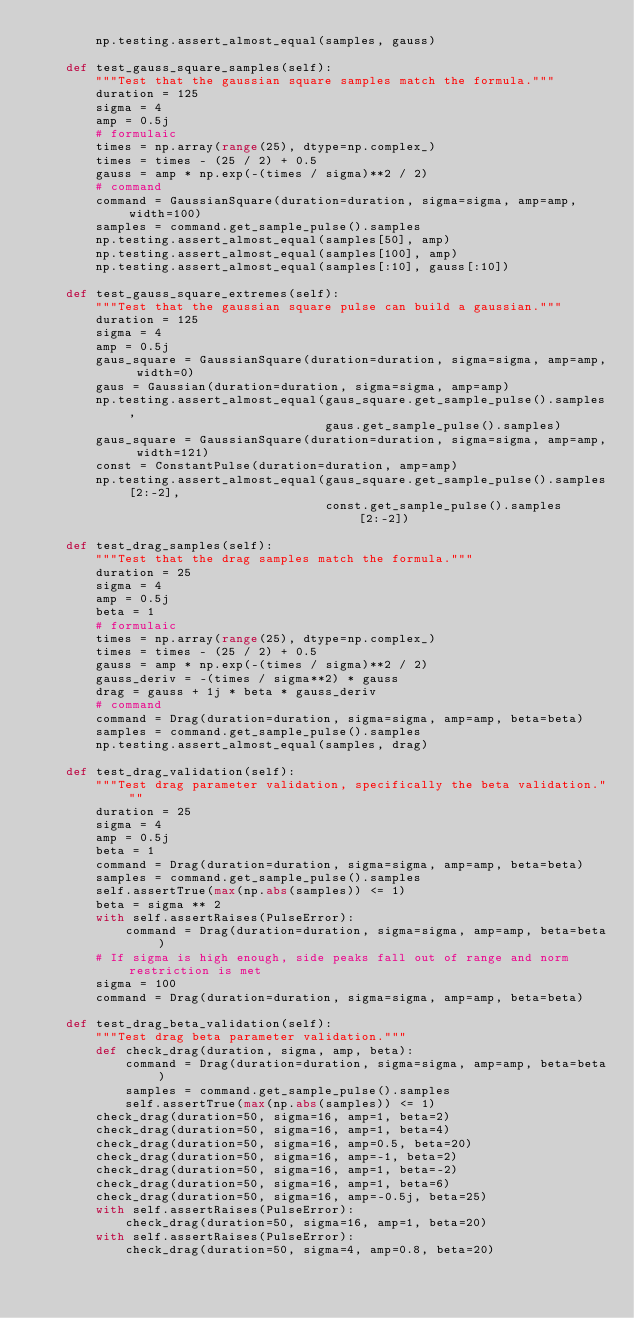<code> <loc_0><loc_0><loc_500><loc_500><_Python_>        np.testing.assert_almost_equal(samples, gauss)

    def test_gauss_square_samples(self):
        """Test that the gaussian square samples match the formula."""
        duration = 125
        sigma = 4
        amp = 0.5j
        # formulaic
        times = np.array(range(25), dtype=np.complex_)
        times = times - (25 / 2) + 0.5
        gauss = amp * np.exp(-(times / sigma)**2 / 2)
        # command
        command = GaussianSquare(duration=duration, sigma=sigma, amp=amp, width=100)
        samples = command.get_sample_pulse().samples
        np.testing.assert_almost_equal(samples[50], amp)
        np.testing.assert_almost_equal(samples[100], amp)
        np.testing.assert_almost_equal(samples[:10], gauss[:10])

    def test_gauss_square_extremes(self):
        """Test that the gaussian square pulse can build a gaussian."""
        duration = 125
        sigma = 4
        amp = 0.5j
        gaus_square = GaussianSquare(duration=duration, sigma=sigma, amp=amp, width=0)
        gaus = Gaussian(duration=duration, sigma=sigma, amp=amp)
        np.testing.assert_almost_equal(gaus_square.get_sample_pulse().samples,
                                       gaus.get_sample_pulse().samples)
        gaus_square = GaussianSquare(duration=duration, sigma=sigma, amp=amp, width=121)
        const = ConstantPulse(duration=duration, amp=amp)
        np.testing.assert_almost_equal(gaus_square.get_sample_pulse().samples[2:-2],
                                       const.get_sample_pulse().samples[2:-2])

    def test_drag_samples(self):
        """Test that the drag samples match the formula."""
        duration = 25
        sigma = 4
        amp = 0.5j
        beta = 1
        # formulaic
        times = np.array(range(25), dtype=np.complex_)
        times = times - (25 / 2) + 0.5
        gauss = amp * np.exp(-(times / sigma)**2 / 2)
        gauss_deriv = -(times / sigma**2) * gauss
        drag = gauss + 1j * beta * gauss_deriv
        # command
        command = Drag(duration=duration, sigma=sigma, amp=amp, beta=beta)
        samples = command.get_sample_pulse().samples
        np.testing.assert_almost_equal(samples, drag)

    def test_drag_validation(self):
        """Test drag parameter validation, specifically the beta validation."""
        duration = 25
        sigma = 4
        amp = 0.5j
        beta = 1
        command = Drag(duration=duration, sigma=sigma, amp=amp, beta=beta)
        samples = command.get_sample_pulse().samples
        self.assertTrue(max(np.abs(samples)) <= 1)
        beta = sigma ** 2
        with self.assertRaises(PulseError):
            command = Drag(duration=duration, sigma=sigma, amp=amp, beta=beta)
        # If sigma is high enough, side peaks fall out of range and norm restriction is met
        sigma = 100
        command = Drag(duration=duration, sigma=sigma, amp=amp, beta=beta)

    def test_drag_beta_validation(self):
        """Test drag beta parameter validation."""
        def check_drag(duration, sigma, amp, beta):
            command = Drag(duration=duration, sigma=sigma, amp=amp, beta=beta)
            samples = command.get_sample_pulse().samples
            self.assertTrue(max(np.abs(samples)) <= 1)
        check_drag(duration=50, sigma=16, amp=1, beta=2)
        check_drag(duration=50, sigma=16, amp=1, beta=4)
        check_drag(duration=50, sigma=16, amp=0.5, beta=20)
        check_drag(duration=50, sigma=16, amp=-1, beta=2)
        check_drag(duration=50, sigma=16, amp=1, beta=-2)
        check_drag(duration=50, sigma=16, amp=1, beta=6)
        check_drag(duration=50, sigma=16, amp=-0.5j, beta=25)
        with self.assertRaises(PulseError):
            check_drag(duration=50, sigma=16, amp=1, beta=20)
        with self.assertRaises(PulseError):
            check_drag(duration=50, sigma=4, amp=0.8, beta=20)
</code> 